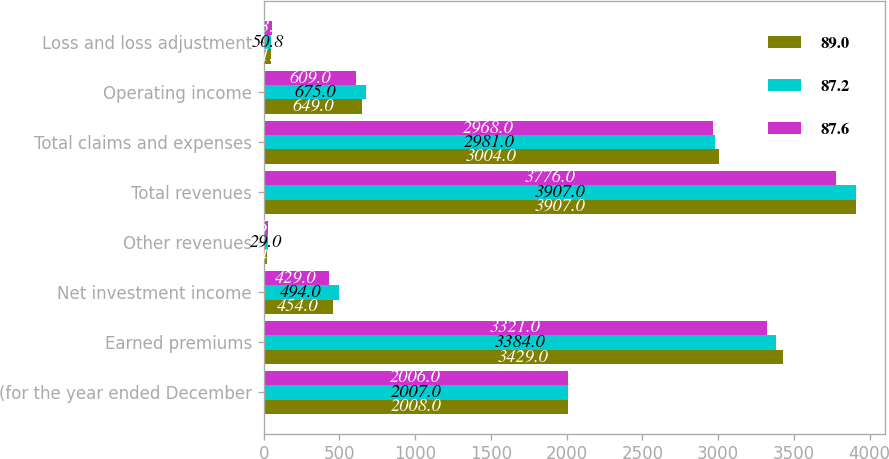Convert chart. <chart><loc_0><loc_0><loc_500><loc_500><stacked_bar_chart><ecel><fcel>(for the year ended December<fcel>Earned premiums<fcel>Net investment income<fcel>Other revenues<fcel>Total revenues<fcel>Total claims and expenses<fcel>Operating income<fcel>Loss and loss adjustment<nl><fcel>89<fcel>2008<fcel>3429<fcel>454<fcel>24<fcel>3907<fcel>3004<fcel>649<fcel>51.2<nl><fcel>87.2<fcel>2007<fcel>3384<fcel>494<fcel>29<fcel>3907<fcel>2981<fcel>675<fcel>50.8<nl><fcel>87.6<fcel>2006<fcel>3321<fcel>429<fcel>26<fcel>3776<fcel>2968<fcel>609<fcel>53.7<nl></chart> 